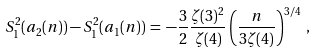Convert formula to latex. <formula><loc_0><loc_0><loc_500><loc_500>S _ { 1 } ^ { 2 } ( a _ { 2 } ( n ) ) - S _ { 1 } ^ { 2 } ( a _ { 1 } ( n ) ) \, = \, - \frac { 3 } { 2 } \frac { \zeta ( 3 ) ^ { 2 } } { \zeta ( 4 ) } \left ( \frac { n } { 3 \zeta ( 4 ) } \right ) ^ { 3 / 4 } \, ,</formula> 